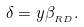<formula> <loc_0><loc_0><loc_500><loc_500>\delta = y \beta _ { _ { R D } } .</formula> 